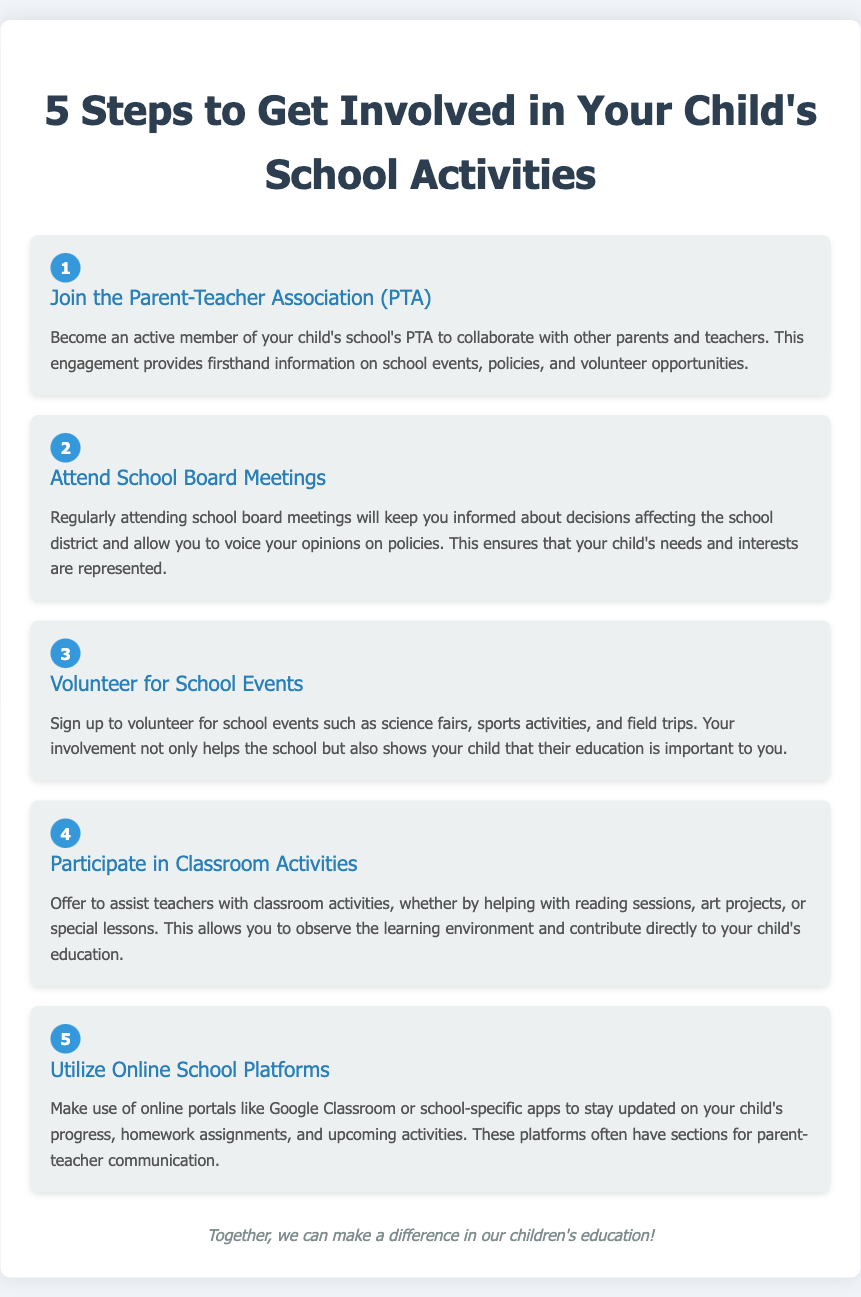What is the first step to get involved? The first step listed in the document for getting involved in your child's school activities is joining the Parent-Teacher Association (PTA).
Answer: Join the Parent-Teacher Association (PTA) How many steps are there to get involved? The document outlines a total of five steps to get involved in your child's school activities.
Answer: Five What should you do to stay updated on your child's progress? To stay updated on your child's progress, you should utilize online school platforms mentioned in the document.
Answer: Utilize Online School Platforms What is a suggested activity in step three? Step three suggests volunteering for school events such as science fairs and sports activities.
Answer: Volunteer for School Events Which step involves attending meetings? The second step involves attending school board meetings to stay informed about decisions affecting the school district.
Answer: Attend School Board Meetings What is the main goal of participating in classroom activities? The main goal of participating in classroom activities is to observe the learning environment and directly contribute to your child's education.
Answer: Observe the learning environment What is highlighted as a benefit of volunteering? Volunteering shows your child that their education is important to you, which is emphasized in the document.
Answer: Shows importance of education Is there a specific platform mentioned for parent-teacher communication? Yes, the document mentions making use of online portals like Google Classroom for parent-teacher communication.
Answer: Google Classroom 